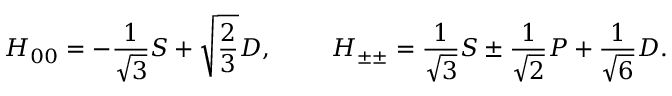Convert formula to latex. <formula><loc_0><loc_0><loc_500><loc_500>H _ { 0 0 } = - { \frac { 1 } { \sqrt { 3 } } } S + \sqrt { { \frac { 2 } { 3 } } } D , H _ { \pm \pm } = { \frac { 1 } { \sqrt { 3 } } } S \pm { \frac { 1 } { \sqrt { 2 } } } P + { \frac { 1 } { \sqrt { 6 } } } D .</formula> 